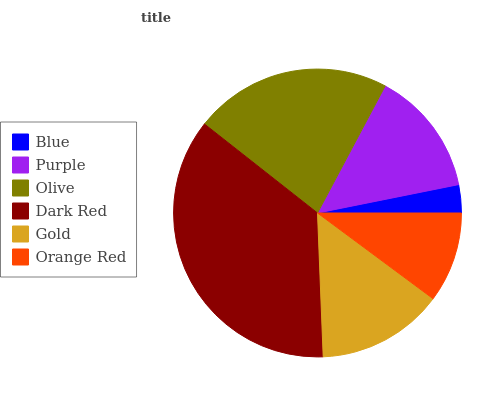Is Blue the minimum?
Answer yes or no. Yes. Is Dark Red the maximum?
Answer yes or no. Yes. Is Purple the minimum?
Answer yes or no. No. Is Purple the maximum?
Answer yes or no. No. Is Purple greater than Blue?
Answer yes or no. Yes. Is Blue less than Purple?
Answer yes or no. Yes. Is Blue greater than Purple?
Answer yes or no. No. Is Purple less than Blue?
Answer yes or no. No. Is Gold the high median?
Answer yes or no. Yes. Is Purple the low median?
Answer yes or no. Yes. Is Blue the high median?
Answer yes or no. No. Is Blue the low median?
Answer yes or no. No. 